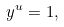<formula> <loc_0><loc_0><loc_500><loc_500>y ^ { u } = 1 ,</formula> 